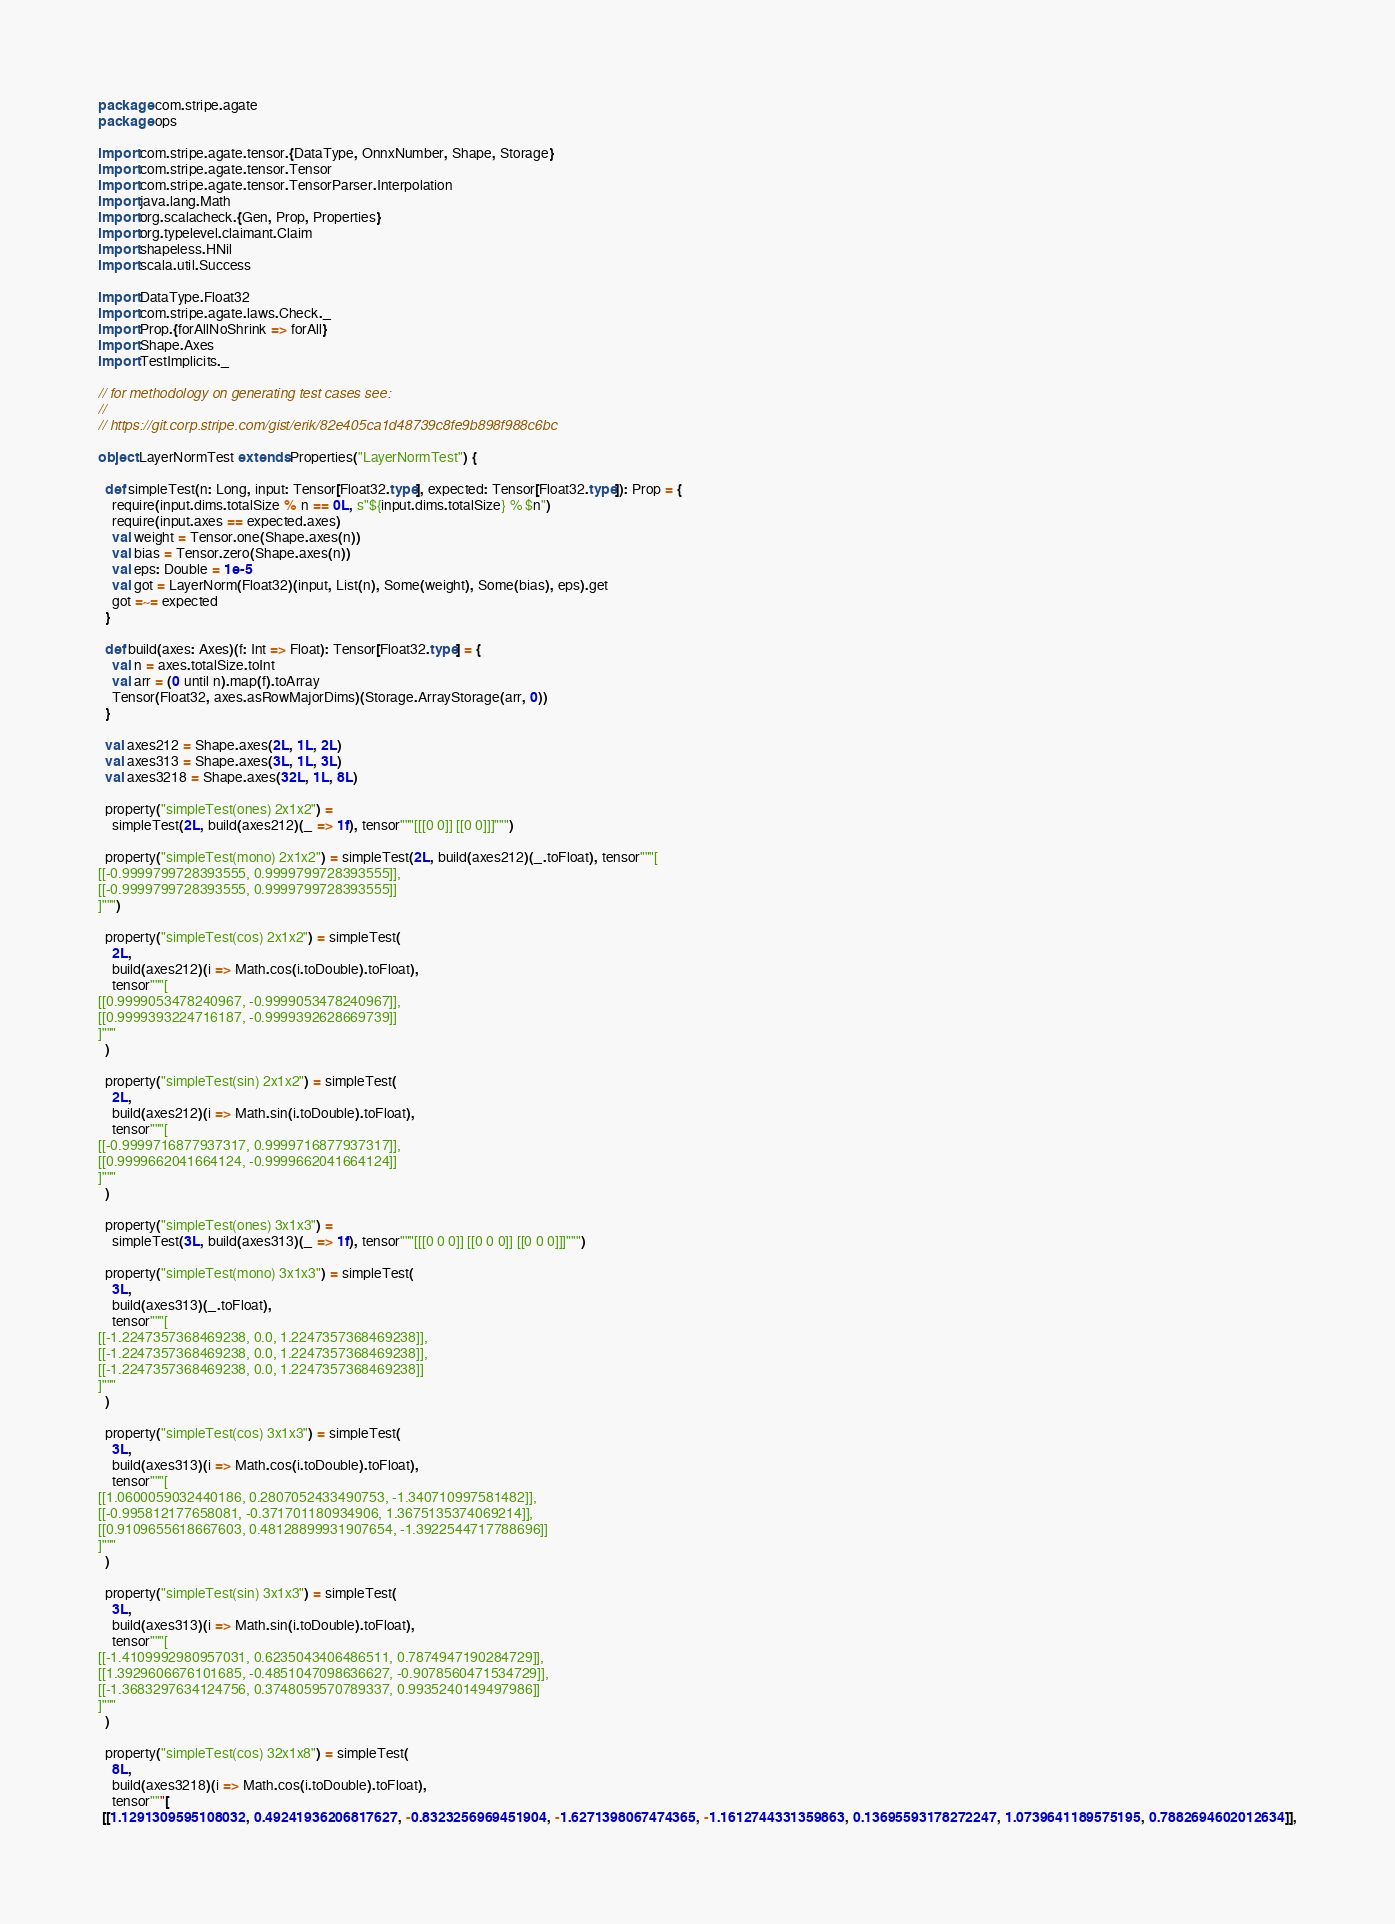Convert code to text. <code><loc_0><loc_0><loc_500><loc_500><_Scala_>package com.stripe.agate
package ops

import com.stripe.agate.tensor.{DataType, OnnxNumber, Shape, Storage}
import com.stripe.agate.tensor.Tensor
import com.stripe.agate.tensor.TensorParser.Interpolation
import java.lang.Math
import org.scalacheck.{Gen, Prop, Properties}
import org.typelevel.claimant.Claim
import shapeless.HNil
import scala.util.Success

import DataType.Float32
import com.stripe.agate.laws.Check._
import Prop.{forAllNoShrink => forAll}
import Shape.Axes
import TestImplicits._

// for methodology on generating test cases see:
//
// https://git.corp.stripe.com/gist/erik/82e405ca1d48739c8fe9b898f988c6bc

object LayerNormTest extends Properties("LayerNormTest") {

  def simpleTest(n: Long, input: Tensor[Float32.type], expected: Tensor[Float32.type]): Prop = {
    require(input.dims.totalSize % n == 0L, s"${input.dims.totalSize} % $n")
    require(input.axes == expected.axes)
    val weight = Tensor.one(Shape.axes(n))
    val bias = Tensor.zero(Shape.axes(n))
    val eps: Double = 1e-5
    val got = LayerNorm(Float32)(input, List(n), Some(weight), Some(bias), eps).get
    got =~= expected
  }

  def build(axes: Axes)(f: Int => Float): Tensor[Float32.type] = {
    val n = axes.totalSize.toInt
    val arr = (0 until n).map(f).toArray
    Tensor(Float32, axes.asRowMajorDims)(Storage.ArrayStorage(arr, 0))
  }

  val axes212 = Shape.axes(2L, 1L, 2L)
  val axes313 = Shape.axes(3L, 1L, 3L)
  val axes3218 = Shape.axes(32L, 1L, 8L)

  property("simpleTest(ones) 2x1x2") =
    simpleTest(2L, build(axes212)(_ => 1f), tensor"""[[[0 0]] [[0 0]]]""")

  property("simpleTest(mono) 2x1x2") = simpleTest(2L, build(axes212)(_.toFloat), tensor"""[
[[-0.9999799728393555, 0.9999799728393555]],
[[-0.9999799728393555, 0.9999799728393555]]
]""")

  property("simpleTest(cos) 2x1x2") = simpleTest(
    2L,
    build(axes212)(i => Math.cos(i.toDouble).toFloat),
    tensor"""[
[[0.9999053478240967, -0.9999053478240967]],
[[0.9999393224716187, -0.9999392628669739]]
]"""
  )

  property("simpleTest(sin) 2x1x2") = simpleTest(
    2L,
    build(axes212)(i => Math.sin(i.toDouble).toFloat),
    tensor"""[
[[-0.9999716877937317, 0.9999716877937317]],
[[0.9999662041664124, -0.9999662041664124]]
]"""
  )

  property("simpleTest(ones) 3x1x3") =
    simpleTest(3L, build(axes313)(_ => 1f), tensor"""[[[0 0 0]] [[0 0 0]] [[0 0 0]]]""")

  property("simpleTest(mono) 3x1x3") = simpleTest(
    3L,
    build(axes313)(_.toFloat),
    tensor"""[
[[-1.2247357368469238, 0.0, 1.2247357368469238]],
[[-1.2247357368469238, 0.0, 1.2247357368469238]],
[[-1.2247357368469238, 0.0, 1.2247357368469238]]
]"""
  )

  property("simpleTest(cos) 3x1x3") = simpleTest(
    3L,
    build(axes313)(i => Math.cos(i.toDouble).toFloat),
    tensor"""[
[[1.0600059032440186, 0.2807052433490753, -1.340710997581482]],
[[-0.995812177658081, -0.371701180934906, 1.3675135374069214]],
[[0.9109655618667603, 0.48128899931907654, -1.3922544717788696]]
]"""
  )

  property("simpleTest(sin) 3x1x3") = simpleTest(
    3L,
    build(axes313)(i => Math.sin(i.toDouble).toFloat),
    tensor"""[
[[-1.4109992980957031, 0.6235043406486511, 0.7874947190284729]],
[[1.3929606676101685, -0.4851047098636627, -0.9078560471534729]],
[[-1.3683297634124756, 0.3748059570789337, 0.9935240149497986]]
]"""
  )

  property("simpleTest(cos) 32x1x8") = simpleTest(
    8L,
    build(axes3218)(i => Math.cos(i.toDouble).toFloat),
    tensor"""[
 [[1.1291309595108032, 0.49241936206817627, -0.8323256969451904, -1.6271398067474365, -1.1612744331359863, 0.13695593178272247, 1.0739641189575195, 0.7882694602012634]],</code> 